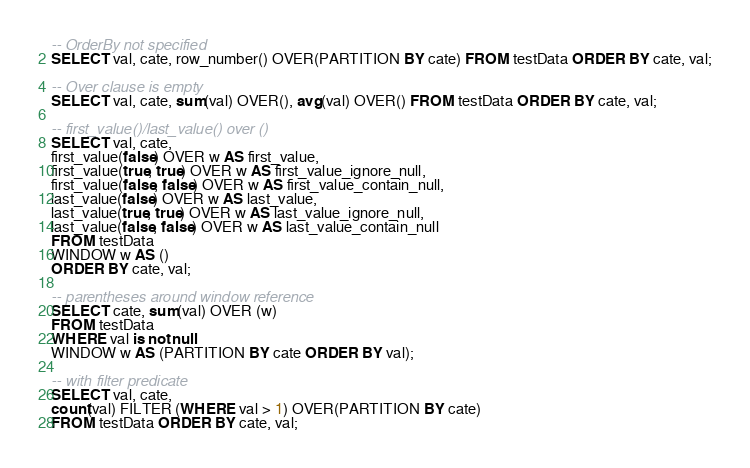Convert code to text. <code><loc_0><loc_0><loc_500><loc_500><_SQL_>
-- OrderBy not specified
SELECT val, cate, row_number() OVER(PARTITION BY cate) FROM testData ORDER BY cate, val;

-- Over clause is empty
SELECT val, cate, sum(val) OVER(), avg(val) OVER() FROM testData ORDER BY cate, val;

-- first_value()/last_value() over ()
SELECT val, cate,
first_value(false) OVER w AS first_value,
first_value(true, true) OVER w AS first_value_ignore_null,
first_value(false, false) OVER w AS first_value_contain_null,
last_value(false) OVER w AS last_value,
last_value(true, true) OVER w AS last_value_ignore_null,
last_value(false, false) OVER w AS last_value_contain_null
FROM testData
WINDOW w AS ()
ORDER BY cate, val;

-- parentheses around window reference
SELECT cate, sum(val) OVER (w)
FROM testData
WHERE val is not null
WINDOW w AS (PARTITION BY cate ORDER BY val);

-- with filter predicate
SELECT val, cate,
count(val) FILTER (WHERE val > 1) OVER(PARTITION BY cate)
FROM testData ORDER BY cate, val;</code> 